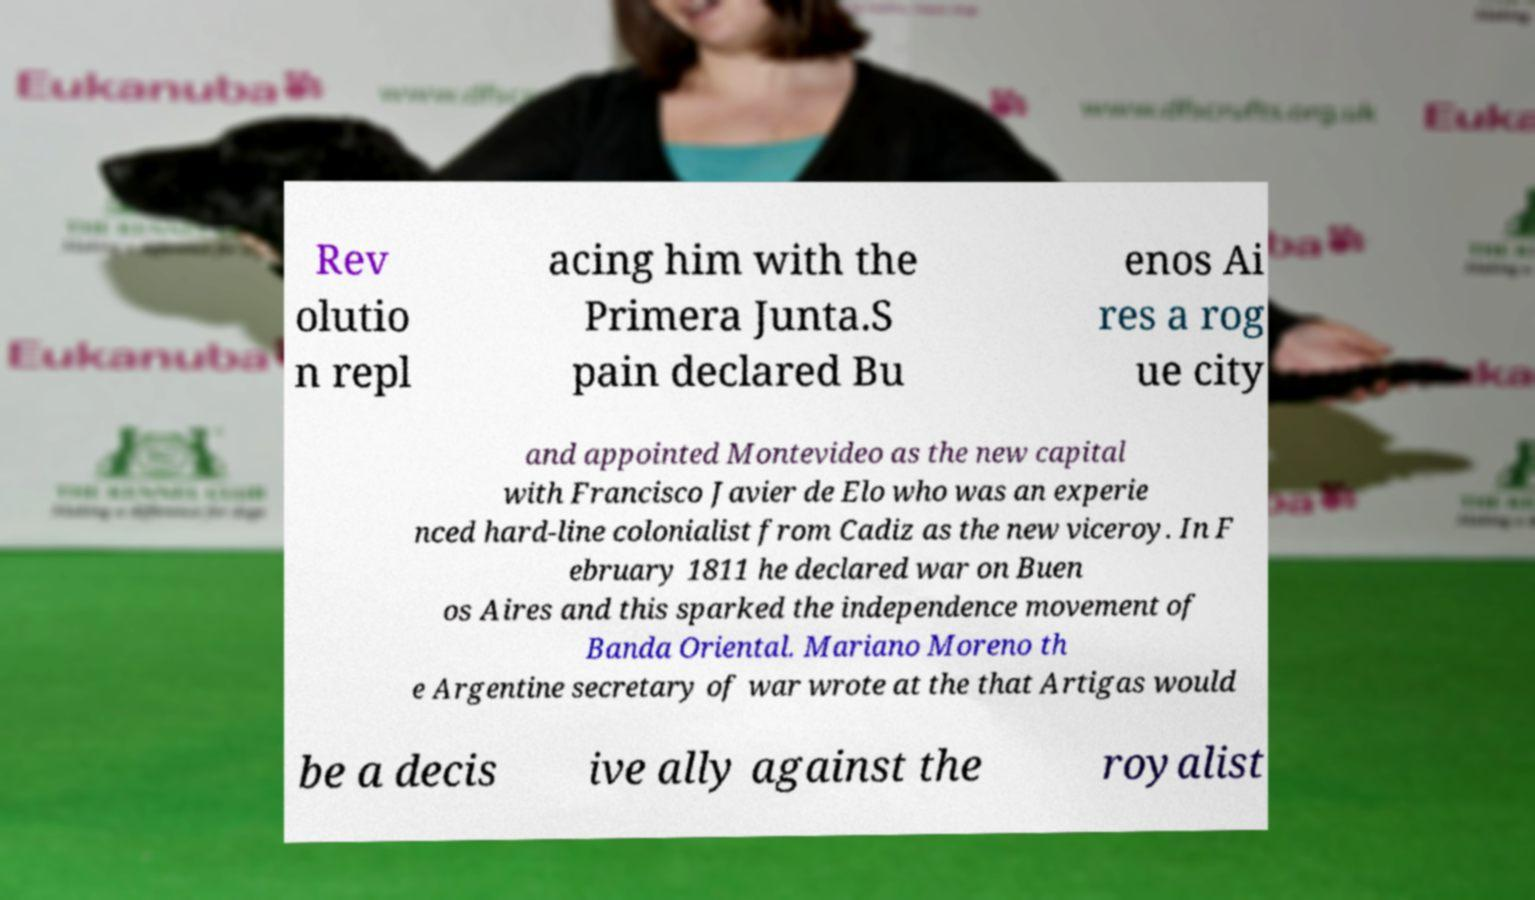Please read and relay the text visible in this image. What does it say? Rev olutio n repl acing him with the Primera Junta.S pain declared Bu enos Ai res a rog ue city and appointed Montevideo as the new capital with Francisco Javier de Elo who was an experie nced hard-line colonialist from Cadiz as the new viceroy. In F ebruary 1811 he declared war on Buen os Aires and this sparked the independence movement of Banda Oriental. Mariano Moreno th e Argentine secretary of war wrote at the that Artigas would be a decis ive ally against the royalist 